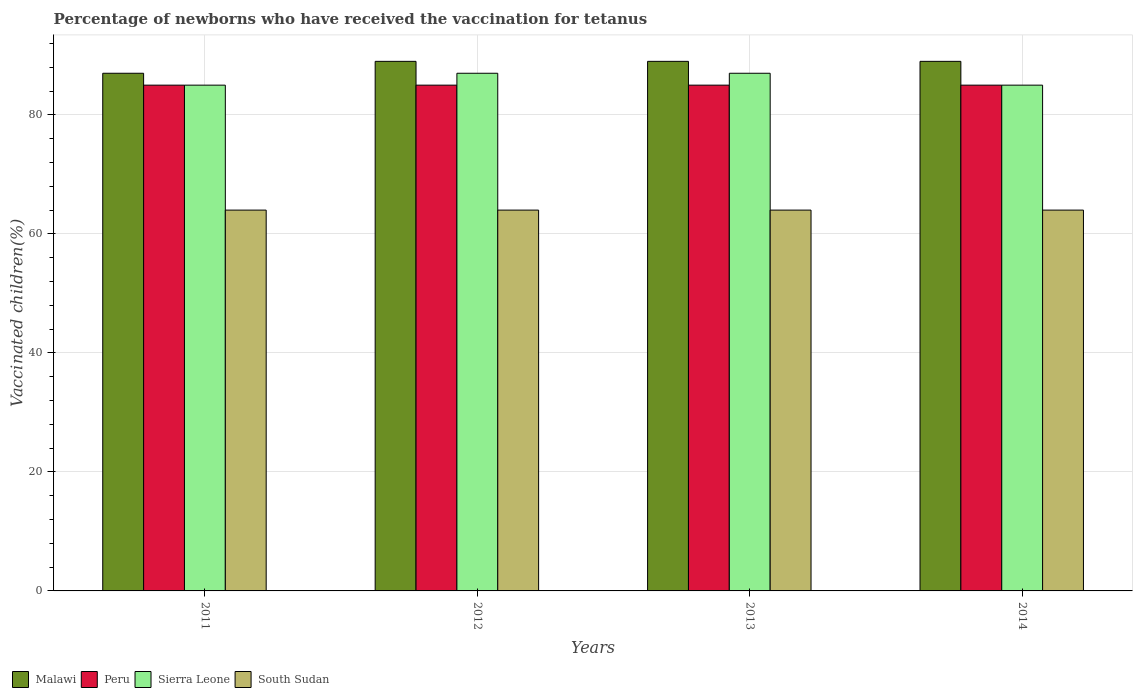How many groups of bars are there?
Provide a short and direct response. 4. Are the number of bars per tick equal to the number of legend labels?
Make the answer very short. Yes. How many bars are there on the 4th tick from the left?
Offer a very short reply. 4. What is the label of the 4th group of bars from the left?
Your answer should be very brief. 2014. In how many cases, is the number of bars for a given year not equal to the number of legend labels?
Offer a very short reply. 0. What is the percentage of vaccinated children in Peru in 2011?
Offer a very short reply. 85. Across all years, what is the maximum percentage of vaccinated children in Sierra Leone?
Your answer should be compact. 87. In which year was the percentage of vaccinated children in Sierra Leone maximum?
Make the answer very short. 2012. What is the total percentage of vaccinated children in Peru in the graph?
Your response must be concise. 340. What is the difference between the percentage of vaccinated children in Sierra Leone in 2012 and that in 2013?
Ensure brevity in your answer.  0. What is the difference between the percentage of vaccinated children in Sierra Leone in 2011 and the percentage of vaccinated children in South Sudan in 2014?
Ensure brevity in your answer.  21. What is the average percentage of vaccinated children in Sierra Leone per year?
Your response must be concise. 86. What is the ratio of the percentage of vaccinated children in Sierra Leone in 2011 to that in 2012?
Keep it short and to the point. 0.98. Is the percentage of vaccinated children in Peru in 2013 less than that in 2014?
Make the answer very short. No. What is the difference between the highest and the second highest percentage of vaccinated children in Peru?
Make the answer very short. 0. What is the difference between the highest and the lowest percentage of vaccinated children in Sierra Leone?
Your response must be concise. 2. Is the sum of the percentage of vaccinated children in Malawi in 2012 and 2014 greater than the maximum percentage of vaccinated children in Sierra Leone across all years?
Your answer should be very brief. Yes. Is it the case that in every year, the sum of the percentage of vaccinated children in Malawi and percentage of vaccinated children in Sierra Leone is greater than the sum of percentage of vaccinated children in Peru and percentage of vaccinated children in South Sudan?
Offer a terse response. Yes. What does the 3rd bar from the left in 2012 represents?
Offer a terse response. Sierra Leone. Is it the case that in every year, the sum of the percentage of vaccinated children in South Sudan and percentage of vaccinated children in Malawi is greater than the percentage of vaccinated children in Sierra Leone?
Give a very brief answer. Yes. How many bars are there?
Your answer should be very brief. 16. Are all the bars in the graph horizontal?
Your response must be concise. No. How many years are there in the graph?
Make the answer very short. 4. What is the difference between two consecutive major ticks on the Y-axis?
Your answer should be very brief. 20. What is the title of the graph?
Ensure brevity in your answer.  Percentage of newborns who have received the vaccination for tetanus. Does "Zimbabwe" appear as one of the legend labels in the graph?
Offer a very short reply. No. What is the label or title of the Y-axis?
Provide a short and direct response. Vaccinated children(%). What is the Vaccinated children(%) in Peru in 2011?
Provide a succinct answer. 85. What is the Vaccinated children(%) of Malawi in 2012?
Provide a succinct answer. 89. What is the Vaccinated children(%) of Peru in 2012?
Ensure brevity in your answer.  85. What is the Vaccinated children(%) in Malawi in 2013?
Your answer should be very brief. 89. What is the Vaccinated children(%) in Sierra Leone in 2013?
Offer a terse response. 87. What is the Vaccinated children(%) in South Sudan in 2013?
Your answer should be compact. 64. What is the Vaccinated children(%) of Malawi in 2014?
Ensure brevity in your answer.  89. What is the Vaccinated children(%) of Peru in 2014?
Ensure brevity in your answer.  85. What is the Vaccinated children(%) in Sierra Leone in 2014?
Make the answer very short. 85. What is the Vaccinated children(%) of South Sudan in 2014?
Keep it short and to the point. 64. Across all years, what is the maximum Vaccinated children(%) in Malawi?
Your answer should be compact. 89. Across all years, what is the maximum Vaccinated children(%) of Sierra Leone?
Your answer should be very brief. 87. Across all years, what is the minimum Vaccinated children(%) of Malawi?
Make the answer very short. 87. Across all years, what is the minimum Vaccinated children(%) in Peru?
Your answer should be compact. 85. Across all years, what is the minimum Vaccinated children(%) of South Sudan?
Ensure brevity in your answer.  64. What is the total Vaccinated children(%) of Malawi in the graph?
Your answer should be compact. 354. What is the total Vaccinated children(%) of Peru in the graph?
Your answer should be very brief. 340. What is the total Vaccinated children(%) of Sierra Leone in the graph?
Make the answer very short. 344. What is the total Vaccinated children(%) in South Sudan in the graph?
Your response must be concise. 256. What is the difference between the Vaccinated children(%) in Peru in 2011 and that in 2012?
Provide a short and direct response. 0. What is the difference between the Vaccinated children(%) of South Sudan in 2011 and that in 2012?
Your response must be concise. 0. What is the difference between the Vaccinated children(%) in Malawi in 2011 and that in 2013?
Keep it short and to the point. -2. What is the difference between the Vaccinated children(%) of Sierra Leone in 2011 and that in 2013?
Your answer should be compact. -2. What is the difference between the Vaccinated children(%) in South Sudan in 2011 and that in 2013?
Your response must be concise. 0. What is the difference between the Vaccinated children(%) of Malawi in 2012 and that in 2013?
Ensure brevity in your answer.  0. What is the difference between the Vaccinated children(%) in Sierra Leone in 2012 and that in 2013?
Your answer should be compact. 0. What is the difference between the Vaccinated children(%) in South Sudan in 2012 and that in 2014?
Give a very brief answer. 0. What is the difference between the Vaccinated children(%) in Sierra Leone in 2013 and that in 2014?
Your answer should be very brief. 2. What is the difference between the Vaccinated children(%) of Malawi in 2011 and the Vaccinated children(%) of Peru in 2012?
Your response must be concise. 2. What is the difference between the Vaccinated children(%) of Malawi in 2011 and the Vaccinated children(%) of Sierra Leone in 2012?
Provide a short and direct response. 0. What is the difference between the Vaccinated children(%) of Peru in 2011 and the Vaccinated children(%) of Sierra Leone in 2012?
Your response must be concise. -2. What is the difference between the Vaccinated children(%) of Sierra Leone in 2011 and the Vaccinated children(%) of South Sudan in 2012?
Ensure brevity in your answer.  21. What is the difference between the Vaccinated children(%) of Malawi in 2011 and the Vaccinated children(%) of Peru in 2013?
Make the answer very short. 2. What is the difference between the Vaccinated children(%) in Malawi in 2011 and the Vaccinated children(%) in South Sudan in 2013?
Offer a terse response. 23. What is the difference between the Vaccinated children(%) in Peru in 2011 and the Vaccinated children(%) in Sierra Leone in 2013?
Give a very brief answer. -2. What is the difference between the Vaccinated children(%) in Peru in 2011 and the Vaccinated children(%) in South Sudan in 2013?
Provide a succinct answer. 21. What is the difference between the Vaccinated children(%) in Malawi in 2011 and the Vaccinated children(%) in Peru in 2014?
Keep it short and to the point. 2. What is the difference between the Vaccinated children(%) of Malawi in 2011 and the Vaccinated children(%) of South Sudan in 2014?
Provide a short and direct response. 23. What is the difference between the Vaccinated children(%) in Peru in 2011 and the Vaccinated children(%) in South Sudan in 2014?
Ensure brevity in your answer.  21. What is the difference between the Vaccinated children(%) in Sierra Leone in 2011 and the Vaccinated children(%) in South Sudan in 2014?
Provide a short and direct response. 21. What is the difference between the Vaccinated children(%) in Malawi in 2012 and the Vaccinated children(%) in Peru in 2013?
Your answer should be very brief. 4. What is the difference between the Vaccinated children(%) of Malawi in 2012 and the Vaccinated children(%) of Sierra Leone in 2013?
Keep it short and to the point. 2. What is the difference between the Vaccinated children(%) of Malawi in 2012 and the Vaccinated children(%) of South Sudan in 2013?
Make the answer very short. 25. What is the difference between the Vaccinated children(%) in Sierra Leone in 2012 and the Vaccinated children(%) in South Sudan in 2013?
Provide a short and direct response. 23. What is the difference between the Vaccinated children(%) in Malawi in 2012 and the Vaccinated children(%) in Peru in 2014?
Your answer should be very brief. 4. What is the difference between the Vaccinated children(%) in Peru in 2012 and the Vaccinated children(%) in Sierra Leone in 2014?
Ensure brevity in your answer.  0. What is the difference between the Vaccinated children(%) of Malawi in 2013 and the Vaccinated children(%) of Peru in 2014?
Your answer should be very brief. 4. What is the difference between the Vaccinated children(%) in Malawi in 2013 and the Vaccinated children(%) in Sierra Leone in 2014?
Your answer should be compact. 4. What is the difference between the Vaccinated children(%) in Malawi in 2013 and the Vaccinated children(%) in South Sudan in 2014?
Provide a short and direct response. 25. What is the difference between the Vaccinated children(%) of Peru in 2013 and the Vaccinated children(%) of Sierra Leone in 2014?
Make the answer very short. 0. What is the difference between the Vaccinated children(%) of Sierra Leone in 2013 and the Vaccinated children(%) of South Sudan in 2014?
Ensure brevity in your answer.  23. What is the average Vaccinated children(%) of Malawi per year?
Your answer should be very brief. 88.5. What is the average Vaccinated children(%) of Sierra Leone per year?
Give a very brief answer. 86. In the year 2011, what is the difference between the Vaccinated children(%) of Malawi and Vaccinated children(%) of Sierra Leone?
Your answer should be very brief. 2. In the year 2011, what is the difference between the Vaccinated children(%) of Malawi and Vaccinated children(%) of South Sudan?
Your answer should be very brief. 23. In the year 2011, what is the difference between the Vaccinated children(%) in Sierra Leone and Vaccinated children(%) in South Sudan?
Your response must be concise. 21. In the year 2012, what is the difference between the Vaccinated children(%) in Malawi and Vaccinated children(%) in Peru?
Provide a succinct answer. 4. In the year 2012, what is the difference between the Vaccinated children(%) of Malawi and Vaccinated children(%) of South Sudan?
Your answer should be very brief. 25. In the year 2012, what is the difference between the Vaccinated children(%) of Peru and Vaccinated children(%) of Sierra Leone?
Give a very brief answer. -2. In the year 2012, what is the difference between the Vaccinated children(%) of Peru and Vaccinated children(%) of South Sudan?
Offer a terse response. 21. In the year 2012, what is the difference between the Vaccinated children(%) in Sierra Leone and Vaccinated children(%) in South Sudan?
Provide a succinct answer. 23. In the year 2013, what is the difference between the Vaccinated children(%) of Malawi and Vaccinated children(%) of South Sudan?
Keep it short and to the point. 25. In the year 2013, what is the difference between the Vaccinated children(%) of Peru and Vaccinated children(%) of Sierra Leone?
Offer a very short reply. -2. In the year 2013, what is the difference between the Vaccinated children(%) in Peru and Vaccinated children(%) in South Sudan?
Offer a terse response. 21. In the year 2014, what is the difference between the Vaccinated children(%) of Malawi and Vaccinated children(%) of Peru?
Offer a terse response. 4. In the year 2014, what is the difference between the Vaccinated children(%) in Malawi and Vaccinated children(%) in Sierra Leone?
Offer a very short reply. 4. In the year 2014, what is the difference between the Vaccinated children(%) of Malawi and Vaccinated children(%) of South Sudan?
Your response must be concise. 25. In the year 2014, what is the difference between the Vaccinated children(%) of Peru and Vaccinated children(%) of Sierra Leone?
Make the answer very short. 0. In the year 2014, what is the difference between the Vaccinated children(%) of Peru and Vaccinated children(%) of South Sudan?
Provide a short and direct response. 21. In the year 2014, what is the difference between the Vaccinated children(%) in Sierra Leone and Vaccinated children(%) in South Sudan?
Your response must be concise. 21. What is the ratio of the Vaccinated children(%) of Malawi in 2011 to that in 2012?
Your answer should be very brief. 0.98. What is the ratio of the Vaccinated children(%) in South Sudan in 2011 to that in 2012?
Keep it short and to the point. 1. What is the ratio of the Vaccinated children(%) in Malawi in 2011 to that in 2013?
Give a very brief answer. 0.98. What is the ratio of the Vaccinated children(%) in Peru in 2011 to that in 2013?
Provide a succinct answer. 1. What is the ratio of the Vaccinated children(%) of Sierra Leone in 2011 to that in 2013?
Provide a short and direct response. 0.98. What is the ratio of the Vaccinated children(%) of South Sudan in 2011 to that in 2013?
Your answer should be very brief. 1. What is the ratio of the Vaccinated children(%) in Malawi in 2011 to that in 2014?
Give a very brief answer. 0.98. What is the ratio of the Vaccinated children(%) of Malawi in 2012 to that in 2013?
Provide a short and direct response. 1. What is the ratio of the Vaccinated children(%) of Peru in 2012 to that in 2013?
Provide a short and direct response. 1. What is the ratio of the Vaccinated children(%) in Sierra Leone in 2012 to that in 2013?
Offer a very short reply. 1. What is the ratio of the Vaccinated children(%) in South Sudan in 2012 to that in 2013?
Your answer should be very brief. 1. What is the ratio of the Vaccinated children(%) of Malawi in 2012 to that in 2014?
Offer a terse response. 1. What is the ratio of the Vaccinated children(%) in Sierra Leone in 2012 to that in 2014?
Offer a very short reply. 1.02. What is the ratio of the Vaccinated children(%) in South Sudan in 2012 to that in 2014?
Provide a short and direct response. 1. What is the ratio of the Vaccinated children(%) of Peru in 2013 to that in 2014?
Offer a terse response. 1. What is the ratio of the Vaccinated children(%) of Sierra Leone in 2013 to that in 2014?
Give a very brief answer. 1.02. What is the ratio of the Vaccinated children(%) in South Sudan in 2013 to that in 2014?
Make the answer very short. 1. What is the difference between the highest and the second highest Vaccinated children(%) of Sierra Leone?
Provide a succinct answer. 0. What is the difference between the highest and the lowest Vaccinated children(%) of Peru?
Make the answer very short. 0. 